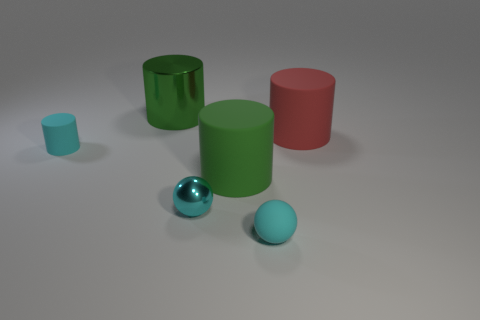How would you describe the overall mood or atmosphere created by the image? The overall mood of the image is calm and neutral. The simplistic setup and pastel colors give it a clean and minimalist aesthetic. 